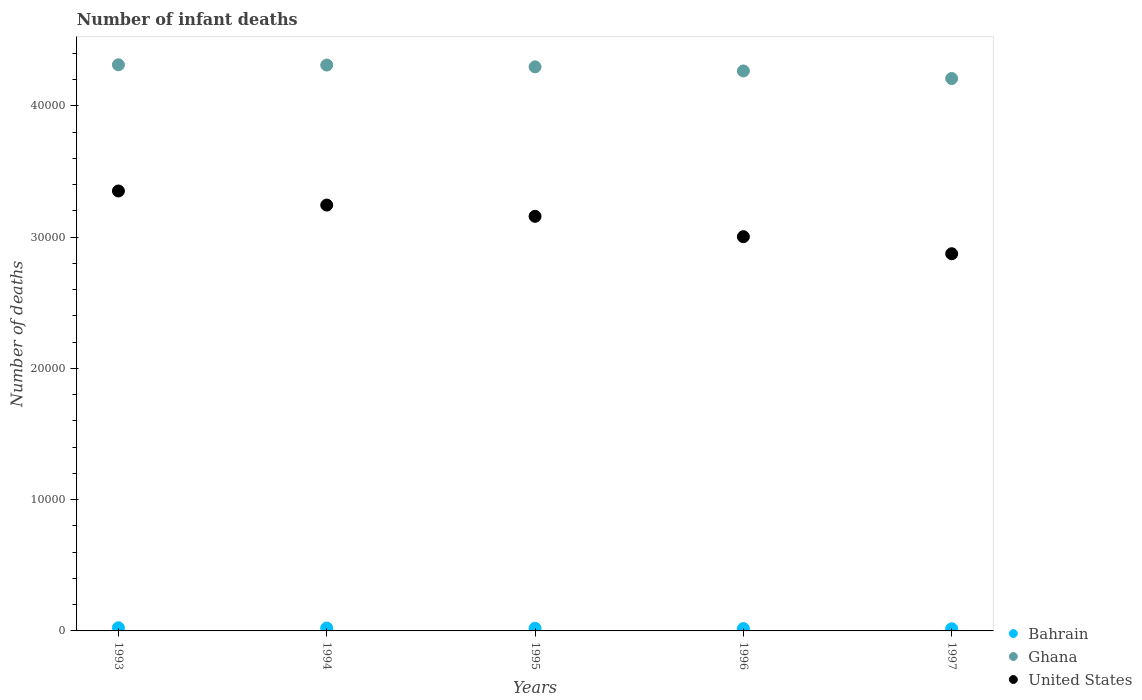How many different coloured dotlines are there?
Ensure brevity in your answer.  3. Is the number of dotlines equal to the number of legend labels?
Your answer should be very brief. Yes. What is the number of infant deaths in United States in 1997?
Provide a succinct answer. 2.87e+04. Across all years, what is the maximum number of infant deaths in United States?
Provide a succinct answer. 3.35e+04. Across all years, what is the minimum number of infant deaths in Bahrain?
Your answer should be very brief. 163. In which year was the number of infant deaths in United States maximum?
Your answer should be very brief. 1993. What is the total number of infant deaths in United States in the graph?
Ensure brevity in your answer.  1.56e+05. What is the difference between the number of infant deaths in Ghana in 1993 and that in 1995?
Offer a very short reply. 159. What is the difference between the number of infant deaths in Ghana in 1993 and the number of infant deaths in Bahrain in 1995?
Your answer should be compact. 4.29e+04. What is the average number of infant deaths in United States per year?
Your response must be concise. 3.13e+04. In the year 1996, what is the difference between the number of infant deaths in Bahrain and number of infant deaths in United States?
Ensure brevity in your answer.  -2.99e+04. In how many years, is the number of infant deaths in Ghana greater than 10000?
Your response must be concise. 5. What is the ratio of the number of infant deaths in Ghana in 1993 to that in 1996?
Ensure brevity in your answer.  1.01. Is the number of infant deaths in Ghana in 1993 less than that in 1994?
Your answer should be compact. No. Is the difference between the number of infant deaths in Bahrain in 1995 and 1996 greater than the difference between the number of infant deaths in United States in 1995 and 1996?
Keep it short and to the point. No. What is the difference between the highest and the second highest number of infant deaths in Ghana?
Provide a succinct answer. 21. What is the difference between the highest and the lowest number of infant deaths in Ghana?
Provide a short and direct response. 1047. Does the number of infant deaths in Bahrain monotonically increase over the years?
Keep it short and to the point. No. Is the number of infant deaths in Ghana strictly greater than the number of infant deaths in United States over the years?
Keep it short and to the point. Yes. How many years are there in the graph?
Your answer should be very brief. 5. What is the difference between two consecutive major ticks on the Y-axis?
Your response must be concise. 10000. Does the graph contain any zero values?
Offer a very short reply. No. Where does the legend appear in the graph?
Provide a succinct answer. Bottom right. How many legend labels are there?
Your answer should be compact. 3. How are the legend labels stacked?
Make the answer very short. Vertical. What is the title of the graph?
Offer a terse response. Number of infant deaths. What is the label or title of the X-axis?
Your answer should be very brief. Years. What is the label or title of the Y-axis?
Your answer should be very brief. Number of deaths. What is the Number of deaths in Bahrain in 1993?
Give a very brief answer. 242. What is the Number of deaths in Ghana in 1993?
Keep it short and to the point. 4.31e+04. What is the Number of deaths of United States in 1993?
Your response must be concise. 3.35e+04. What is the Number of deaths of Bahrain in 1994?
Make the answer very short. 221. What is the Number of deaths in Ghana in 1994?
Offer a terse response. 4.31e+04. What is the Number of deaths of United States in 1994?
Your response must be concise. 3.24e+04. What is the Number of deaths in Bahrain in 1995?
Ensure brevity in your answer.  199. What is the Number of deaths of Ghana in 1995?
Offer a very short reply. 4.30e+04. What is the Number of deaths in United States in 1995?
Your answer should be very brief. 3.16e+04. What is the Number of deaths of Bahrain in 1996?
Your answer should be compact. 178. What is the Number of deaths of Ghana in 1996?
Offer a terse response. 4.27e+04. What is the Number of deaths in United States in 1996?
Provide a succinct answer. 3.00e+04. What is the Number of deaths of Bahrain in 1997?
Your answer should be very brief. 163. What is the Number of deaths in Ghana in 1997?
Your answer should be compact. 4.21e+04. What is the Number of deaths of United States in 1997?
Keep it short and to the point. 2.87e+04. Across all years, what is the maximum Number of deaths in Bahrain?
Provide a succinct answer. 242. Across all years, what is the maximum Number of deaths of Ghana?
Provide a short and direct response. 4.31e+04. Across all years, what is the maximum Number of deaths in United States?
Give a very brief answer. 3.35e+04. Across all years, what is the minimum Number of deaths in Bahrain?
Make the answer very short. 163. Across all years, what is the minimum Number of deaths of Ghana?
Provide a short and direct response. 4.21e+04. Across all years, what is the minimum Number of deaths of United States?
Keep it short and to the point. 2.87e+04. What is the total Number of deaths in Bahrain in the graph?
Make the answer very short. 1003. What is the total Number of deaths of Ghana in the graph?
Offer a very short reply. 2.14e+05. What is the total Number of deaths of United States in the graph?
Give a very brief answer. 1.56e+05. What is the difference between the Number of deaths in United States in 1993 and that in 1994?
Provide a short and direct response. 1073. What is the difference between the Number of deaths in Ghana in 1993 and that in 1995?
Ensure brevity in your answer.  159. What is the difference between the Number of deaths in United States in 1993 and that in 1995?
Your answer should be compact. 1931. What is the difference between the Number of deaths of Ghana in 1993 and that in 1996?
Give a very brief answer. 469. What is the difference between the Number of deaths in United States in 1993 and that in 1996?
Keep it short and to the point. 3482. What is the difference between the Number of deaths in Bahrain in 1993 and that in 1997?
Your answer should be compact. 79. What is the difference between the Number of deaths of Ghana in 1993 and that in 1997?
Your response must be concise. 1047. What is the difference between the Number of deaths in United States in 1993 and that in 1997?
Keep it short and to the point. 4781. What is the difference between the Number of deaths of Ghana in 1994 and that in 1995?
Make the answer very short. 138. What is the difference between the Number of deaths in United States in 1994 and that in 1995?
Offer a terse response. 858. What is the difference between the Number of deaths in Bahrain in 1994 and that in 1996?
Provide a short and direct response. 43. What is the difference between the Number of deaths in Ghana in 1994 and that in 1996?
Provide a short and direct response. 448. What is the difference between the Number of deaths in United States in 1994 and that in 1996?
Ensure brevity in your answer.  2409. What is the difference between the Number of deaths in Ghana in 1994 and that in 1997?
Offer a very short reply. 1026. What is the difference between the Number of deaths in United States in 1994 and that in 1997?
Your answer should be very brief. 3708. What is the difference between the Number of deaths in Bahrain in 1995 and that in 1996?
Offer a very short reply. 21. What is the difference between the Number of deaths in Ghana in 1995 and that in 1996?
Your answer should be compact. 310. What is the difference between the Number of deaths in United States in 1995 and that in 1996?
Keep it short and to the point. 1551. What is the difference between the Number of deaths in Bahrain in 1995 and that in 1997?
Ensure brevity in your answer.  36. What is the difference between the Number of deaths of Ghana in 1995 and that in 1997?
Your answer should be compact. 888. What is the difference between the Number of deaths in United States in 1995 and that in 1997?
Your answer should be compact. 2850. What is the difference between the Number of deaths in Bahrain in 1996 and that in 1997?
Give a very brief answer. 15. What is the difference between the Number of deaths in Ghana in 1996 and that in 1997?
Make the answer very short. 578. What is the difference between the Number of deaths in United States in 1996 and that in 1997?
Make the answer very short. 1299. What is the difference between the Number of deaths of Bahrain in 1993 and the Number of deaths of Ghana in 1994?
Offer a very short reply. -4.29e+04. What is the difference between the Number of deaths of Bahrain in 1993 and the Number of deaths of United States in 1994?
Offer a very short reply. -3.22e+04. What is the difference between the Number of deaths of Ghana in 1993 and the Number of deaths of United States in 1994?
Your response must be concise. 1.07e+04. What is the difference between the Number of deaths of Bahrain in 1993 and the Number of deaths of Ghana in 1995?
Provide a short and direct response. -4.27e+04. What is the difference between the Number of deaths of Bahrain in 1993 and the Number of deaths of United States in 1995?
Provide a short and direct response. -3.14e+04. What is the difference between the Number of deaths in Ghana in 1993 and the Number of deaths in United States in 1995?
Keep it short and to the point. 1.15e+04. What is the difference between the Number of deaths in Bahrain in 1993 and the Number of deaths in Ghana in 1996?
Your response must be concise. -4.24e+04. What is the difference between the Number of deaths of Bahrain in 1993 and the Number of deaths of United States in 1996?
Your answer should be compact. -2.98e+04. What is the difference between the Number of deaths in Ghana in 1993 and the Number of deaths in United States in 1996?
Your response must be concise. 1.31e+04. What is the difference between the Number of deaths in Bahrain in 1993 and the Number of deaths in Ghana in 1997?
Make the answer very short. -4.19e+04. What is the difference between the Number of deaths of Bahrain in 1993 and the Number of deaths of United States in 1997?
Ensure brevity in your answer.  -2.85e+04. What is the difference between the Number of deaths of Ghana in 1993 and the Number of deaths of United States in 1997?
Provide a short and direct response. 1.44e+04. What is the difference between the Number of deaths in Bahrain in 1994 and the Number of deaths in Ghana in 1995?
Provide a short and direct response. -4.28e+04. What is the difference between the Number of deaths in Bahrain in 1994 and the Number of deaths in United States in 1995?
Offer a very short reply. -3.14e+04. What is the difference between the Number of deaths in Ghana in 1994 and the Number of deaths in United States in 1995?
Offer a terse response. 1.15e+04. What is the difference between the Number of deaths in Bahrain in 1994 and the Number of deaths in Ghana in 1996?
Provide a short and direct response. -4.24e+04. What is the difference between the Number of deaths of Bahrain in 1994 and the Number of deaths of United States in 1996?
Keep it short and to the point. -2.98e+04. What is the difference between the Number of deaths in Ghana in 1994 and the Number of deaths in United States in 1996?
Your response must be concise. 1.31e+04. What is the difference between the Number of deaths of Bahrain in 1994 and the Number of deaths of Ghana in 1997?
Offer a terse response. -4.19e+04. What is the difference between the Number of deaths in Bahrain in 1994 and the Number of deaths in United States in 1997?
Ensure brevity in your answer.  -2.85e+04. What is the difference between the Number of deaths of Ghana in 1994 and the Number of deaths of United States in 1997?
Provide a short and direct response. 1.44e+04. What is the difference between the Number of deaths of Bahrain in 1995 and the Number of deaths of Ghana in 1996?
Provide a short and direct response. -4.25e+04. What is the difference between the Number of deaths in Bahrain in 1995 and the Number of deaths in United States in 1996?
Your response must be concise. -2.98e+04. What is the difference between the Number of deaths in Ghana in 1995 and the Number of deaths in United States in 1996?
Offer a very short reply. 1.29e+04. What is the difference between the Number of deaths in Bahrain in 1995 and the Number of deaths in Ghana in 1997?
Provide a short and direct response. -4.19e+04. What is the difference between the Number of deaths in Bahrain in 1995 and the Number of deaths in United States in 1997?
Provide a succinct answer. -2.85e+04. What is the difference between the Number of deaths of Ghana in 1995 and the Number of deaths of United States in 1997?
Your answer should be compact. 1.42e+04. What is the difference between the Number of deaths of Bahrain in 1996 and the Number of deaths of Ghana in 1997?
Provide a succinct answer. -4.19e+04. What is the difference between the Number of deaths in Bahrain in 1996 and the Number of deaths in United States in 1997?
Keep it short and to the point. -2.86e+04. What is the difference between the Number of deaths in Ghana in 1996 and the Number of deaths in United States in 1997?
Ensure brevity in your answer.  1.39e+04. What is the average Number of deaths in Bahrain per year?
Give a very brief answer. 200.6. What is the average Number of deaths of Ghana per year?
Make the answer very short. 4.28e+04. What is the average Number of deaths of United States per year?
Offer a very short reply. 3.13e+04. In the year 1993, what is the difference between the Number of deaths of Bahrain and Number of deaths of Ghana?
Give a very brief answer. -4.29e+04. In the year 1993, what is the difference between the Number of deaths of Bahrain and Number of deaths of United States?
Provide a short and direct response. -3.33e+04. In the year 1993, what is the difference between the Number of deaths in Ghana and Number of deaths in United States?
Your answer should be compact. 9617. In the year 1994, what is the difference between the Number of deaths in Bahrain and Number of deaths in Ghana?
Your answer should be compact. -4.29e+04. In the year 1994, what is the difference between the Number of deaths of Bahrain and Number of deaths of United States?
Offer a very short reply. -3.22e+04. In the year 1994, what is the difference between the Number of deaths in Ghana and Number of deaths in United States?
Your response must be concise. 1.07e+04. In the year 1995, what is the difference between the Number of deaths in Bahrain and Number of deaths in Ghana?
Give a very brief answer. -4.28e+04. In the year 1995, what is the difference between the Number of deaths of Bahrain and Number of deaths of United States?
Your answer should be compact. -3.14e+04. In the year 1995, what is the difference between the Number of deaths of Ghana and Number of deaths of United States?
Your answer should be very brief. 1.14e+04. In the year 1996, what is the difference between the Number of deaths of Bahrain and Number of deaths of Ghana?
Provide a short and direct response. -4.25e+04. In the year 1996, what is the difference between the Number of deaths of Bahrain and Number of deaths of United States?
Offer a very short reply. -2.99e+04. In the year 1996, what is the difference between the Number of deaths of Ghana and Number of deaths of United States?
Offer a terse response. 1.26e+04. In the year 1997, what is the difference between the Number of deaths in Bahrain and Number of deaths in Ghana?
Ensure brevity in your answer.  -4.19e+04. In the year 1997, what is the difference between the Number of deaths of Bahrain and Number of deaths of United States?
Provide a short and direct response. -2.86e+04. In the year 1997, what is the difference between the Number of deaths of Ghana and Number of deaths of United States?
Provide a short and direct response. 1.34e+04. What is the ratio of the Number of deaths of Bahrain in 1993 to that in 1994?
Provide a succinct answer. 1.09. What is the ratio of the Number of deaths of Ghana in 1993 to that in 1994?
Your response must be concise. 1. What is the ratio of the Number of deaths in United States in 1993 to that in 1994?
Your response must be concise. 1.03. What is the ratio of the Number of deaths of Bahrain in 1993 to that in 1995?
Provide a succinct answer. 1.22. What is the ratio of the Number of deaths of United States in 1993 to that in 1995?
Provide a succinct answer. 1.06. What is the ratio of the Number of deaths of Bahrain in 1993 to that in 1996?
Provide a short and direct response. 1.36. What is the ratio of the Number of deaths of Ghana in 1993 to that in 1996?
Keep it short and to the point. 1.01. What is the ratio of the Number of deaths of United States in 1993 to that in 1996?
Your answer should be very brief. 1.12. What is the ratio of the Number of deaths in Bahrain in 1993 to that in 1997?
Your answer should be compact. 1.48. What is the ratio of the Number of deaths in Ghana in 1993 to that in 1997?
Provide a short and direct response. 1.02. What is the ratio of the Number of deaths of United States in 1993 to that in 1997?
Give a very brief answer. 1.17. What is the ratio of the Number of deaths in Bahrain in 1994 to that in 1995?
Your answer should be very brief. 1.11. What is the ratio of the Number of deaths of United States in 1994 to that in 1995?
Provide a short and direct response. 1.03. What is the ratio of the Number of deaths of Bahrain in 1994 to that in 1996?
Offer a terse response. 1.24. What is the ratio of the Number of deaths of Ghana in 1994 to that in 1996?
Provide a succinct answer. 1.01. What is the ratio of the Number of deaths of United States in 1994 to that in 1996?
Make the answer very short. 1.08. What is the ratio of the Number of deaths of Bahrain in 1994 to that in 1997?
Make the answer very short. 1.36. What is the ratio of the Number of deaths of Ghana in 1994 to that in 1997?
Your answer should be very brief. 1.02. What is the ratio of the Number of deaths of United States in 1994 to that in 1997?
Make the answer very short. 1.13. What is the ratio of the Number of deaths of Bahrain in 1995 to that in 1996?
Provide a short and direct response. 1.12. What is the ratio of the Number of deaths of Ghana in 1995 to that in 1996?
Your response must be concise. 1.01. What is the ratio of the Number of deaths of United States in 1995 to that in 1996?
Make the answer very short. 1.05. What is the ratio of the Number of deaths of Bahrain in 1995 to that in 1997?
Make the answer very short. 1.22. What is the ratio of the Number of deaths in Ghana in 1995 to that in 1997?
Make the answer very short. 1.02. What is the ratio of the Number of deaths of United States in 1995 to that in 1997?
Give a very brief answer. 1.1. What is the ratio of the Number of deaths of Bahrain in 1996 to that in 1997?
Offer a very short reply. 1.09. What is the ratio of the Number of deaths of Ghana in 1996 to that in 1997?
Ensure brevity in your answer.  1.01. What is the ratio of the Number of deaths of United States in 1996 to that in 1997?
Your answer should be compact. 1.05. What is the difference between the highest and the second highest Number of deaths of Ghana?
Your answer should be compact. 21. What is the difference between the highest and the second highest Number of deaths of United States?
Provide a succinct answer. 1073. What is the difference between the highest and the lowest Number of deaths in Bahrain?
Provide a short and direct response. 79. What is the difference between the highest and the lowest Number of deaths of Ghana?
Keep it short and to the point. 1047. What is the difference between the highest and the lowest Number of deaths of United States?
Offer a terse response. 4781. 